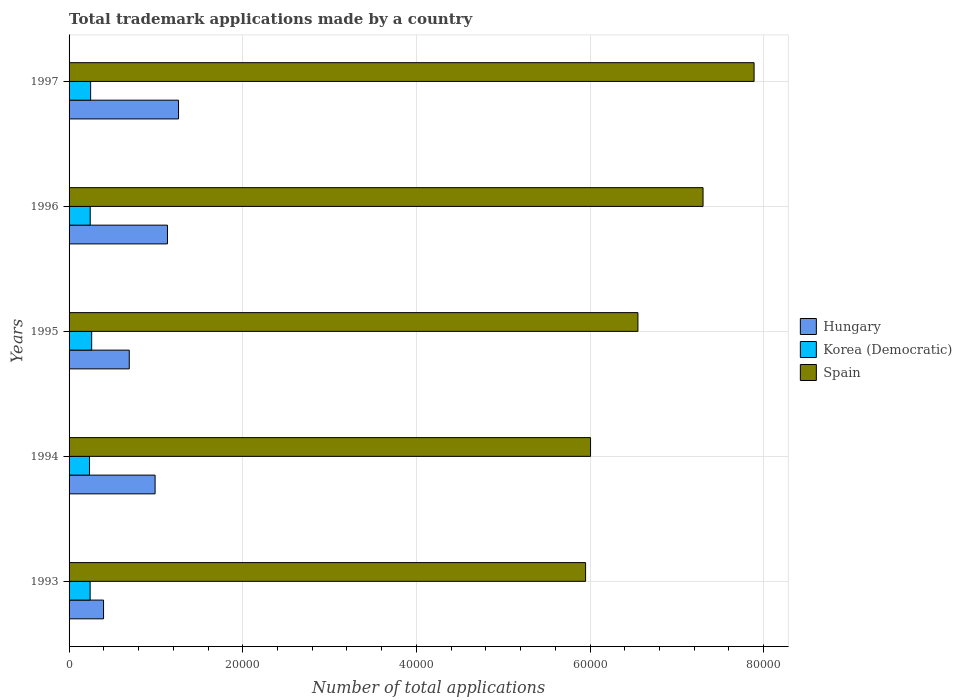How many different coloured bars are there?
Offer a terse response. 3. Are the number of bars on each tick of the Y-axis equal?
Make the answer very short. Yes. What is the label of the 5th group of bars from the top?
Offer a terse response. 1993. What is the number of applications made by in Hungary in 1993?
Offer a terse response. 3970. Across all years, what is the maximum number of applications made by in Korea (Democratic)?
Your response must be concise. 2603. Across all years, what is the minimum number of applications made by in Hungary?
Provide a short and direct response. 3970. What is the total number of applications made by in Korea (Democratic) in the graph?
Offer a terse response. 1.23e+04. What is the difference between the number of applications made by in Korea (Democratic) in 1993 and that in 1996?
Ensure brevity in your answer.  -9. What is the difference between the number of applications made by in Hungary in 1996 and the number of applications made by in Korea (Democratic) in 1995?
Keep it short and to the point. 8730. What is the average number of applications made by in Spain per year?
Give a very brief answer. 6.74e+04. In the year 1996, what is the difference between the number of applications made by in Hungary and number of applications made by in Spain?
Ensure brevity in your answer.  -6.17e+04. What is the ratio of the number of applications made by in Hungary in 1995 to that in 1996?
Offer a very short reply. 0.61. What is the difference between the highest and the second highest number of applications made by in Korea (Democratic)?
Offer a very short reply. 120. What is the difference between the highest and the lowest number of applications made by in Hungary?
Give a very brief answer. 8636. In how many years, is the number of applications made by in Spain greater than the average number of applications made by in Spain taken over all years?
Keep it short and to the point. 2. Is the sum of the number of applications made by in Korea (Democratic) in 1994 and 1995 greater than the maximum number of applications made by in Hungary across all years?
Your response must be concise. No. What does the 3rd bar from the top in 1996 represents?
Provide a succinct answer. Hungary. What does the 3rd bar from the bottom in 1995 represents?
Give a very brief answer. Spain. How many bars are there?
Give a very brief answer. 15. What is the difference between two consecutive major ticks on the X-axis?
Provide a succinct answer. 2.00e+04. Does the graph contain any zero values?
Keep it short and to the point. No. Where does the legend appear in the graph?
Your response must be concise. Center right. How many legend labels are there?
Your answer should be compact. 3. How are the legend labels stacked?
Ensure brevity in your answer.  Vertical. What is the title of the graph?
Provide a short and direct response. Total trademark applications made by a country. What is the label or title of the X-axis?
Offer a very short reply. Number of total applications. What is the Number of total applications in Hungary in 1993?
Offer a very short reply. 3970. What is the Number of total applications of Korea (Democratic) in 1993?
Offer a very short reply. 2427. What is the Number of total applications in Spain in 1993?
Your answer should be very brief. 5.95e+04. What is the Number of total applications of Hungary in 1994?
Offer a terse response. 9908. What is the Number of total applications in Korea (Democratic) in 1994?
Provide a short and direct response. 2353. What is the Number of total applications in Spain in 1994?
Offer a very short reply. 6.01e+04. What is the Number of total applications in Hungary in 1995?
Offer a terse response. 6932. What is the Number of total applications in Korea (Democratic) in 1995?
Keep it short and to the point. 2603. What is the Number of total applications of Spain in 1995?
Ensure brevity in your answer.  6.55e+04. What is the Number of total applications in Hungary in 1996?
Your answer should be very brief. 1.13e+04. What is the Number of total applications in Korea (Democratic) in 1996?
Your response must be concise. 2436. What is the Number of total applications of Spain in 1996?
Provide a succinct answer. 7.30e+04. What is the Number of total applications in Hungary in 1997?
Your answer should be very brief. 1.26e+04. What is the Number of total applications in Korea (Democratic) in 1997?
Provide a succinct answer. 2483. What is the Number of total applications of Spain in 1997?
Ensure brevity in your answer.  7.89e+04. Across all years, what is the maximum Number of total applications in Hungary?
Your answer should be compact. 1.26e+04. Across all years, what is the maximum Number of total applications in Korea (Democratic)?
Give a very brief answer. 2603. Across all years, what is the maximum Number of total applications in Spain?
Your response must be concise. 7.89e+04. Across all years, what is the minimum Number of total applications in Hungary?
Your answer should be very brief. 3970. Across all years, what is the minimum Number of total applications in Korea (Democratic)?
Your answer should be very brief. 2353. Across all years, what is the minimum Number of total applications of Spain?
Your answer should be very brief. 5.95e+04. What is the total Number of total applications in Hungary in the graph?
Your answer should be compact. 4.47e+04. What is the total Number of total applications in Korea (Democratic) in the graph?
Offer a very short reply. 1.23e+04. What is the total Number of total applications in Spain in the graph?
Give a very brief answer. 3.37e+05. What is the difference between the Number of total applications of Hungary in 1993 and that in 1994?
Give a very brief answer. -5938. What is the difference between the Number of total applications in Korea (Democratic) in 1993 and that in 1994?
Provide a succinct answer. 74. What is the difference between the Number of total applications in Spain in 1993 and that in 1994?
Your answer should be compact. -572. What is the difference between the Number of total applications of Hungary in 1993 and that in 1995?
Keep it short and to the point. -2962. What is the difference between the Number of total applications in Korea (Democratic) in 1993 and that in 1995?
Offer a very short reply. -176. What is the difference between the Number of total applications in Spain in 1993 and that in 1995?
Give a very brief answer. -6028. What is the difference between the Number of total applications of Hungary in 1993 and that in 1996?
Offer a very short reply. -7363. What is the difference between the Number of total applications of Korea (Democratic) in 1993 and that in 1996?
Provide a succinct answer. -9. What is the difference between the Number of total applications in Spain in 1993 and that in 1996?
Your answer should be compact. -1.35e+04. What is the difference between the Number of total applications of Hungary in 1993 and that in 1997?
Keep it short and to the point. -8636. What is the difference between the Number of total applications of Korea (Democratic) in 1993 and that in 1997?
Your response must be concise. -56. What is the difference between the Number of total applications in Spain in 1993 and that in 1997?
Offer a very short reply. -1.94e+04. What is the difference between the Number of total applications in Hungary in 1994 and that in 1995?
Your answer should be very brief. 2976. What is the difference between the Number of total applications in Korea (Democratic) in 1994 and that in 1995?
Your answer should be very brief. -250. What is the difference between the Number of total applications in Spain in 1994 and that in 1995?
Keep it short and to the point. -5456. What is the difference between the Number of total applications of Hungary in 1994 and that in 1996?
Provide a short and direct response. -1425. What is the difference between the Number of total applications of Korea (Democratic) in 1994 and that in 1996?
Ensure brevity in your answer.  -83. What is the difference between the Number of total applications of Spain in 1994 and that in 1996?
Offer a terse response. -1.30e+04. What is the difference between the Number of total applications in Hungary in 1994 and that in 1997?
Provide a succinct answer. -2698. What is the difference between the Number of total applications in Korea (Democratic) in 1994 and that in 1997?
Give a very brief answer. -130. What is the difference between the Number of total applications in Spain in 1994 and that in 1997?
Provide a succinct answer. -1.88e+04. What is the difference between the Number of total applications in Hungary in 1995 and that in 1996?
Provide a short and direct response. -4401. What is the difference between the Number of total applications in Korea (Democratic) in 1995 and that in 1996?
Make the answer very short. 167. What is the difference between the Number of total applications of Spain in 1995 and that in 1996?
Provide a short and direct response. -7500. What is the difference between the Number of total applications in Hungary in 1995 and that in 1997?
Give a very brief answer. -5674. What is the difference between the Number of total applications in Korea (Democratic) in 1995 and that in 1997?
Provide a succinct answer. 120. What is the difference between the Number of total applications of Spain in 1995 and that in 1997?
Offer a terse response. -1.34e+04. What is the difference between the Number of total applications of Hungary in 1996 and that in 1997?
Your answer should be compact. -1273. What is the difference between the Number of total applications in Korea (Democratic) in 1996 and that in 1997?
Ensure brevity in your answer.  -47. What is the difference between the Number of total applications in Spain in 1996 and that in 1997?
Offer a very short reply. -5879. What is the difference between the Number of total applications in Hungary in 1993 and the Number of total applications in Korea (Democratic) in 1994?
Your response must be concise. 1617. What is the difference between the Number of total applications of Hungary in 1993 and the Number of total applications of Spain in 1994?
Give a very brief answer. -5.61e+04. What is the difference between the Number of total applications in Korea (Democratic) in 1993 and the Number of total applications in Spain in 1994?
Offer a terse response. -5.76e+04. What is the difference between the Number of total applications in Hungary in 1993 and the Number of total applications in Korea (Democratic) in 1995?
Provide a succinct answer. 1367. What is the difference between the Number of total applications of Hungary in 1993 and the Number of total applications of Spain in 1995?
Provide a succinct answer. -6.15e+04. What is the difference between the Number of total applications of Korea (Democratic) in 1993 and the Number of total applications of Spain in 1995?
Your answer should be very brief. -6.31e+04. What is the difference between the Number of total applications of Hungary in 1993 and the Number of total applications of Korea (Democratic) in 1996?
Your answer should be very brief. 1534. What is the difference between the Number of total applications in Hungary in 1993 and the Number of total applications in Spain in 1996?
Your answer should be compact. -6.90e+04. What is the difference between the Number of total applications in Korea (Democratic) in 1993 and the Number of total applications in Spain in 1996?
Give a very brief answer. -7.06e+04. What is the difference between the Number of total applications of Hungary in 1993 and the Number of total applications of Korea (Democratic) in 1997?
Your answer should be very brief. 1487. What is the difference between the Number of total applications of Hungary in 1993 and the Number of total applications of Spain in 1997?
Provide a succinct answer. -7.49e+04. What is the difference between the Number of total applications of Korea (Democratic) in 1993 and the Number of total applications of Spain in 1997?
Provide a short and direct response. -7.65e+04. What is the difference between the Number of total applications in Hungary in 1994 and the Number of total applications in Korea (Democratic) in 1995?
Give a very brief answer. 7305. What is the difference between the Number of total applications of Hungary in 1994 and the Number of total applications of Spain in 1995?
Your answer should be compact. -5.56e+04. What is the difference between the Number of total applications in Korea (Democratic) in 1994 and the Number of total applications in Spain in 1995?
Offer a terse response. -6.32e+04. What is the difference between the Number of total applications in Hungary in 1994 and the Number of total applications in Korea (Democratic) in 1996?
Offer a very short reply. 7472. What is the difference between the Number of total applications in Hungary in 1994 and the Number of total applications in Spain in 1996?
Ensure brevity in your answer.  -6.31e+04. What is the difference between the Number of total applications in Korea (Democratic) in 1994 and the Number of total applications in Spain in 1996?
Your answer should be compact. -7.07e+04. What is the difference between the Number of total applications of Hungary in 1994 and the Number of total applications of Korea (Democratic) in 1997?
Ensure brevity in your answer.  7425. What is the difference between the Number of total applications in Hungary in 1994 and the Number of total applications in Spain in 1997?
Keep it short and to the point. -6.90e+04. What is the difference between the Number of total applications in Korea (Democratic) in 1994 and the Number of total applications in Spain in 1997?
Keep it short and to the point. -7.65e+04. What is the difference between the Number of total applications in Hungary in 1995 and the Number of total applications in Korea (Democratic) in 1996?
Make the answer very short. 4496. What is the difference between the Number of total applications of Hungary in 1995 and the Number of total applications of Spain in 1996?
Ensure brevity in your answer.  -6.61e+04. What is the difference between the Number of total applications of Korea (Democratic) in 1995 and the Number of total applications of Spain in 1996?
Make the answer very short. -7.04e+04. What is the difference between the Number of total applications of Hungary in 1995 and the Number of total applications of Korea (Democratic) in 1997?
Keep it short and to the point. 4449. What is the difference between the Number of total applications of Hungary in 1995 and the Number of total applications of Spain in 1997?
Offer a very short reply. -7.20e+04. What is the difference between the Number of total applications of Korea (Democratic) in 1995 and the Number of total applications of Spain in 1997?
Provide a succinct answer. -7.63e+04. What is the difference between the Number of total applications of Hungary in 1996 and the Number of total applications of Korea (Democratic) in 1997?
Provide a succinct answer. 8850. What is the difference between the Number of total applications in Hungary in 1996 and the Number of total applications in Spain in 1997?
Your answer should be very brief. -6.76e+04. What is the difference between the Number of total applications of Korea (Democratic) in 1996 and the Number of total applications of Spain in 1997?
Provide a succinct answer. -7.65e+04. What is the average Number of total applications of Hungary per year?
Provide a succinct answer. 8949.8. What is the average Number of total applications of Korea (Democratic) per year?
Provide a succinct answer. 2460.4. What is the average Number of total applications in Spain per year?
Your answer should be compact. 6.74e+04. In the year 1993, what is the difference between the Number of total applications of Hungary and Number of total applications of Korea (Democratic)?
Make the answer very short. 1543. In the year 1993, what is the difference between the Number of total applications in Hungary and Number of total applications in Spain?
Your answer should be compact. -5.55e+04. In the year 1993, what is the difference between the Number of total applications of Korea (Democratic) and Number of total applications of Spain?
Give a very brief answer. -5.71e+04. In the year 1994, what is the difference between the Number of total applications of Hungary and Number of total applications of Korea (Democratic)?
Your answer should be very brief. 7555. In the year 1994, what is the difference between the Number of total applications of Hungary and Number of total applications of Spain?
Keep it short and to the point. -5.02e+04. In the year 1994, what is the difference between the Number of total applications in Korea (Democratic) and Number of total applications in Spain?
Offer a terse response. -5.77e+04. In the year 1995, what is the difference between the Number of total applications of Hungary and Number of total applications of Korea (Democratic)?
Provide a succinct answer. 4329. In the year 1995, what is the difference between the Number of total applications in Hungary and Number of total applications in Spain?
Keep it short and to the point. -5.86e+04. In the year 1995, what is the difference between the Number of total applications in Korea (Democratic) and Number of total applications in Spain?
Offer a very short reply. -6.29e+04. In the year 1996, what is the difference between the Number of total applications in Hungary and Number of total applications in Korea (Democratic)?
Ensure brevity in your answer.  8897. In the year 1996, what is the difference between the Number of total applications in Hungary and Number of total applications in Spain?
Keep it short and to the point. -6.17e+04. In the year 1996, what is the difference between the Number of total applications of Korea (Democratic) and Number of total applications of Spain?
Offer a terse response. -7.06e+04. In the year 1997, what is the difference between the Number of total applications in Hungary and Number of total applications in Korea (Democratic)?
Make the answer very short. 1.01e+04. In the year 1997, what is the difference between the Number of total applications in Hungary and Number of total applications in Spain?
Make the answer very short. -6.63e+04. In the year 1997, what is the difference between the Number of total applications of Korea (Democratic) and Number of total applications of Spain?
Keep it short and to the point. -7.64e+04. What is the ratio of the Number of total applications of Hungary in 1993 to that in 1994?
Keep it short and to the point. 0.4. What is the ratio of the Number of total applications in Korea (Democratic) in 1993 to that in 1994?
Offer a terse response. 1.03. What is the ratio of the Number of total applications of Spain in 1993 to that in 1994?
Offer a terse response. 0.99. What is the ratio of the Number of total applications in Hungary in 1993 to that in 1995?
Your response must be concise. 0.57. What is the ratio of the Number of total applications in Korea (Democratic) in 1993 to that in 1995?
Make the answer very short. 0.93. What is the ratio of the Number of total applications of Spain in 1993 to that in 1995?
Provide a succinct answer. 0.91. What is the ratio of the Number of total applications of Hungary in 1993 to that in 1996?
Offer a very short reply. 0.35. What is the ratio of the Number of total applications in Korea (Democratic) in 1993 to that in 1996?
Provide a short and direct response. 1. What is the ratio of the Number of total applications of Spain in 1993 to that in 1996?
Your answer should be compact. 0.81. What is the ratio of the Number of total applications in Hungary in 1993 to that in 1997?
Make the answer very short. 0.31. What is the ratio of the Number of total applications in Korea (Democratic) in 1993 to that in 1997?
Your response must be concise. 0.98. What is the ratio of the Number of total applications of Spain in 1993 to that in 1997?
Offer a terse response. 0.75. What is the ratio of the Number of total applications of Hungary in 1994 to that in 1995?
Make the answer very short. 1.43. What is the ratio of the Number of total applications in Korea (Democratic) in 1994 to that in 1995?
Keep it short and to the point. 0.9. What is the ratio of the Number of total applications of Spain in 1994 to that in 1995?
Provide a short and direct response. 0.92. What is the ratio of the Number of total applications in Hungary in 1994 to that in 1996?
Offer a very short reply. 0.87. What is the ratio of the Number of total applications of Korea (Democratic) in 1994 to that in 1996?
Ensure brevity in your answer.  0.97. What is the ratio of the Number of total applications of Spain in 1994 to that in 1996?
Offer a terse response. 0.82. What is the ratio of the Number of total applications in Hungary in 1994 to that in 1997?
Offer a terse response. 0.79. What is the ratio of the Number of total applications of Korea (Democratic) in 1994 to that in 1997?
Provide a succinct answer. 0.95. What is the ratio of the Number of total applications of Spain in 1994 to that in 1997?
Your response must be concise. 0.76. What is the ratio of the Number of total applications of Hungary in 1995 to that in 1996?
Your answer should be compact. 0.61. What is the ratio of the Number of total applications in Korea (Democratic) in 1995 to that in 1996?
Ensure brevity in your answer.  1.07. What is the ratio of the Number of total applications of Spain in 1995 to that in 1996?
Provide a succinct answer. 0.9. What is the ratio of the Number of total applications in Hungary in 1995 to that in 1997?
Your answer should be compact. 0.55. What is the ratio of the Number of total applications in Korea (Democratic) in 1995 to that in 1997?
Your answer should be compact. 1.05. What is the ratio of the Number of total applications in Spain in 1995 to that in 1997?
Provide a short and direct response. 0.83. What is the ratio of the Number of total applications of Hungary in 1996 to that in 1997?
Offer a very short reply. 0.9. What is the ratio of the Number of total applications in Korea (Democratic) in 1996 to that in 1997?
Offer a very short reply. 0.98. What is the ratio of the Number of total applications of Spain in 1996 to that in 1997?
Ensure brevity in your answer.  0.93. What is the difference between the highest and the second highest Number of total applications in Hungary?
Your answer should be very brief. 1273. What is the difference between the highest and the second highest Number of total applications of Korea (Democratic)?
Keep it short and to the point. 120. What is the difference between the highest and the second highest Number of total applications in Spain?
Your answer should be compact. 5879. What is the difference between the highest and the lowest Number of total applications of Hungary?
Offer a very short reply. 8636. What is the difference between the highest and the lowest Number of total applications of Korea (Democratic)?
Make the answer very short. 250. What is the difference between the highest and the lowest Number of total applications in Spain?
Provide a succinct answer. 1.94e+04. 